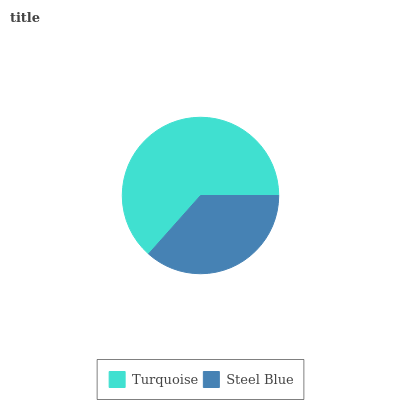Is Steel Blue the minimum?
Answer yes or no. Yes. Is Turquoise the maximum?
Answer yes or no. Yes. Is Steel Blue the maximum?
Answer yes or no. No. Is Turquoise greater than Steel Blue?
Answer yes or no. Yes. Is Steel Blue less than Turquoise?
Answer yes or no. Yes. Is Steel Blue greater than Turquoise?
Answer yes or no. No. Is Turquoise less than Steel Blue?
Answer yes or no. No. Is Turquoise the high median?
Answer yes or no. Yes. Is Steel Blue the low median?
Answer yes or no. Yes. Is Steel Blue the high median?
Answer yes or no. No. Is Turquoise the low median?
Answer yes or no. No. 